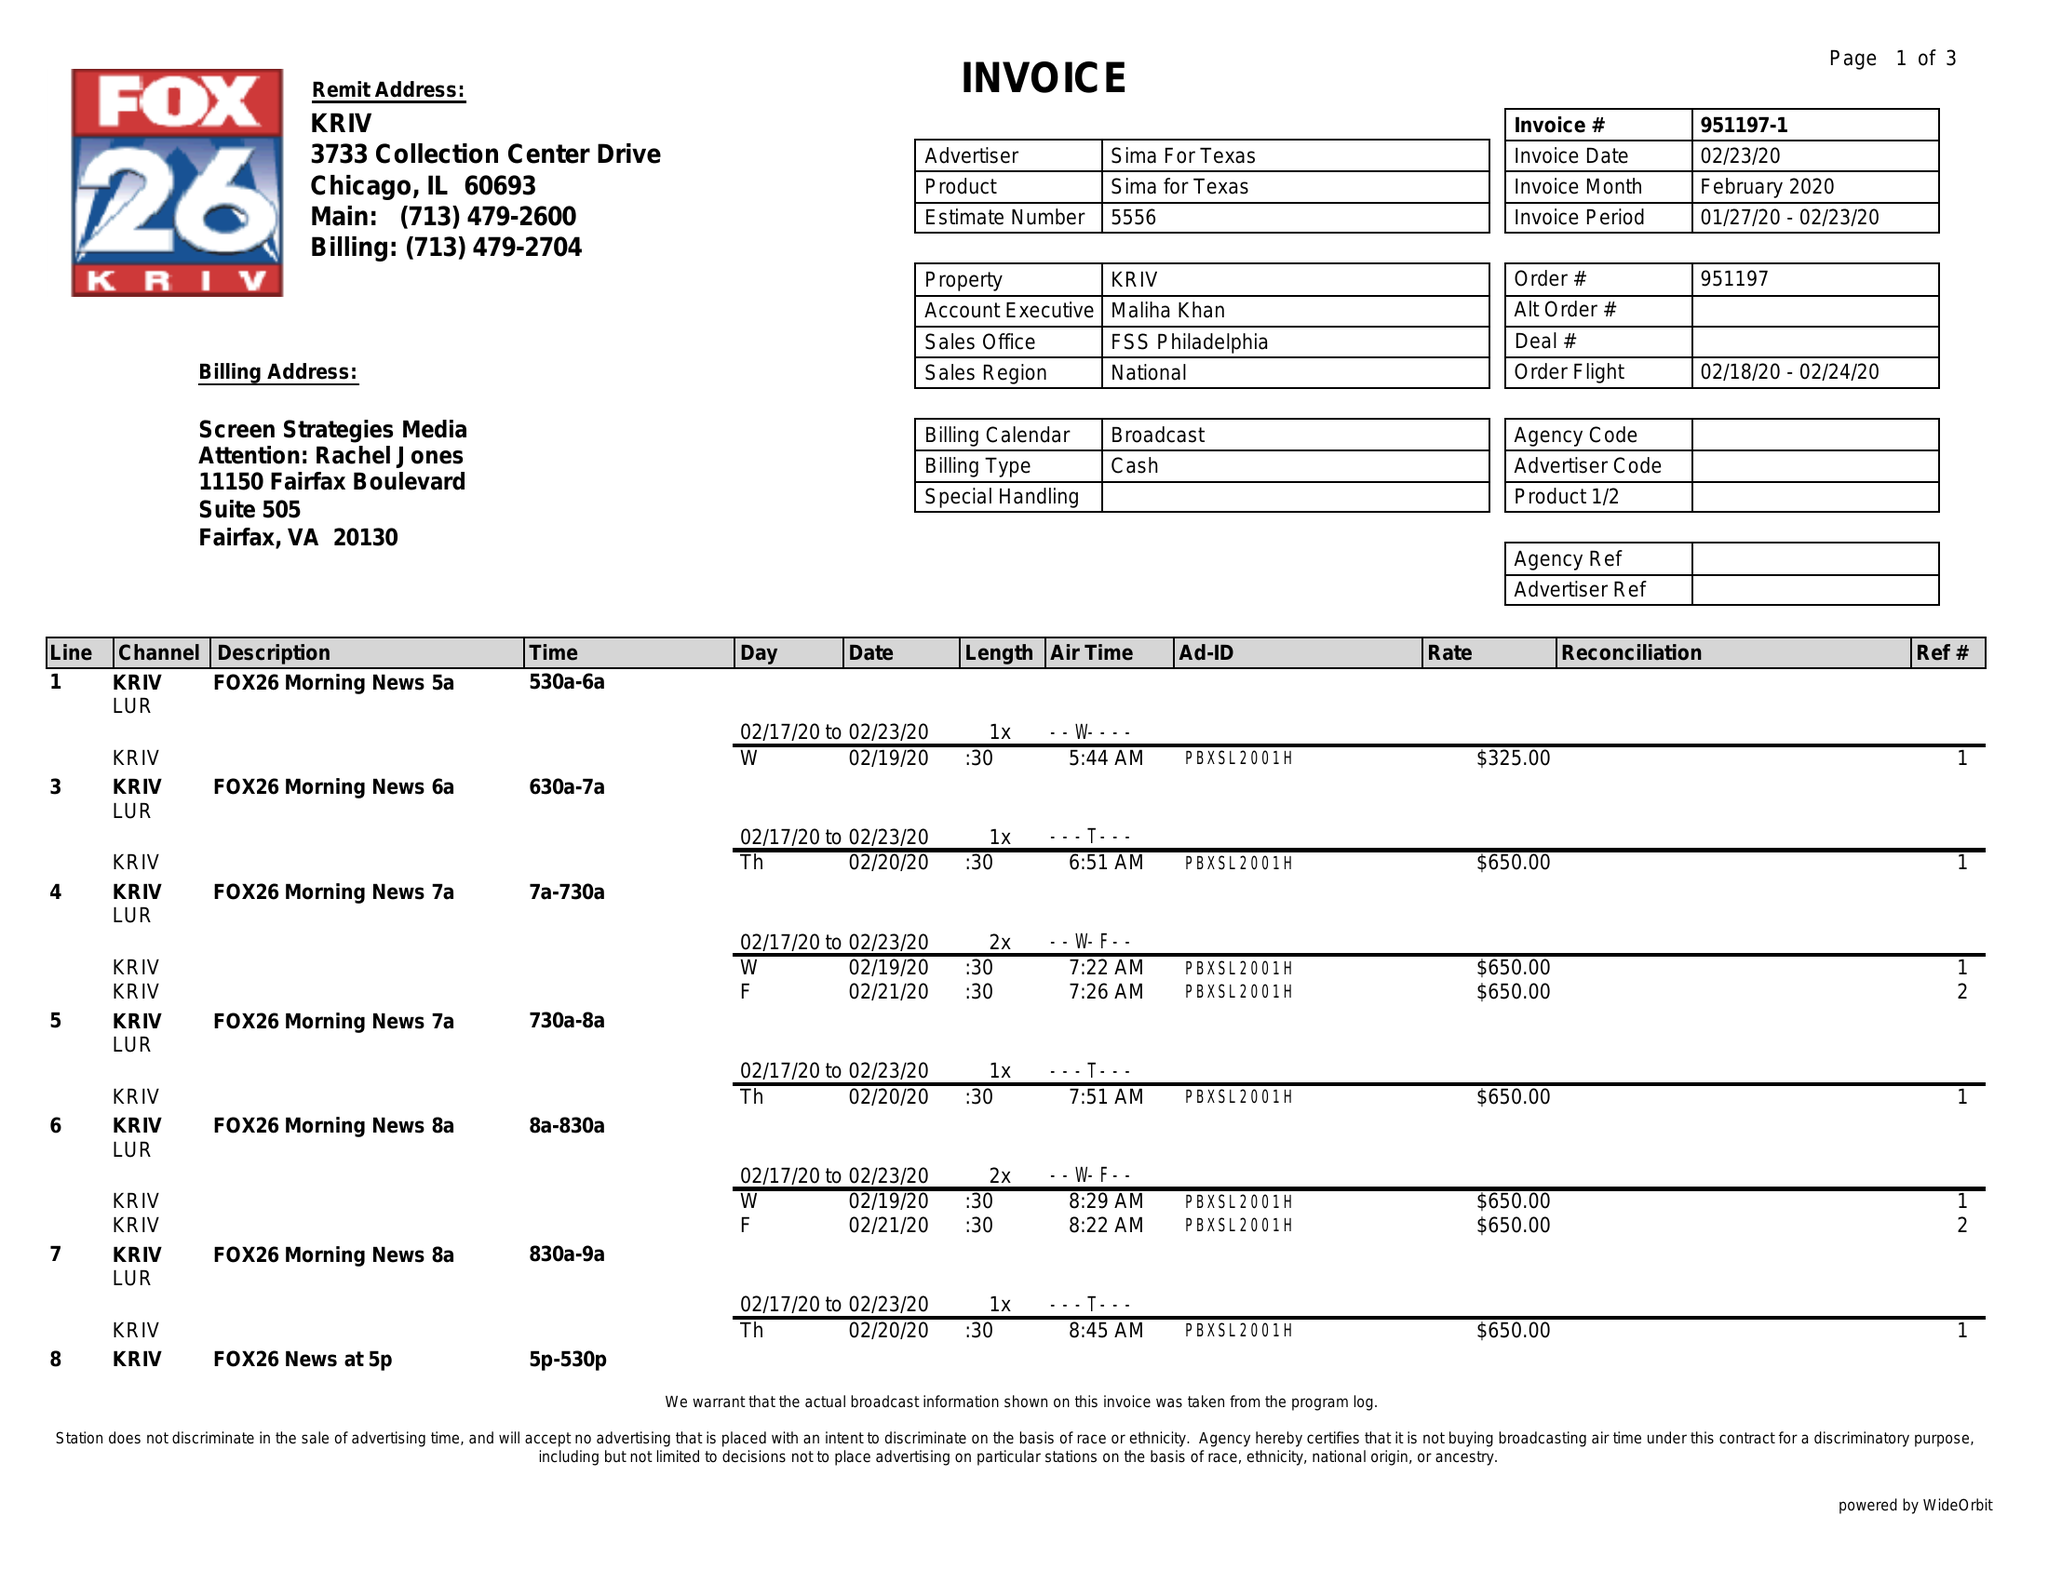What is the value for the advertiser?
Answer the question using a single word or phrase. SIMA FOR TEXAS 